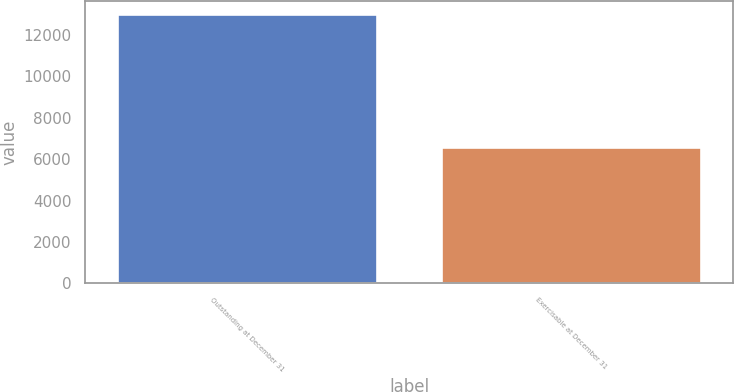<chart> <loc_0><loc_0><loc_500><loc_500><bar_chart><fcel>Outstanding at December 31<fcel>Exercisable at December 31<nl><fcel>13004<fcel>6609<nl></chart> 